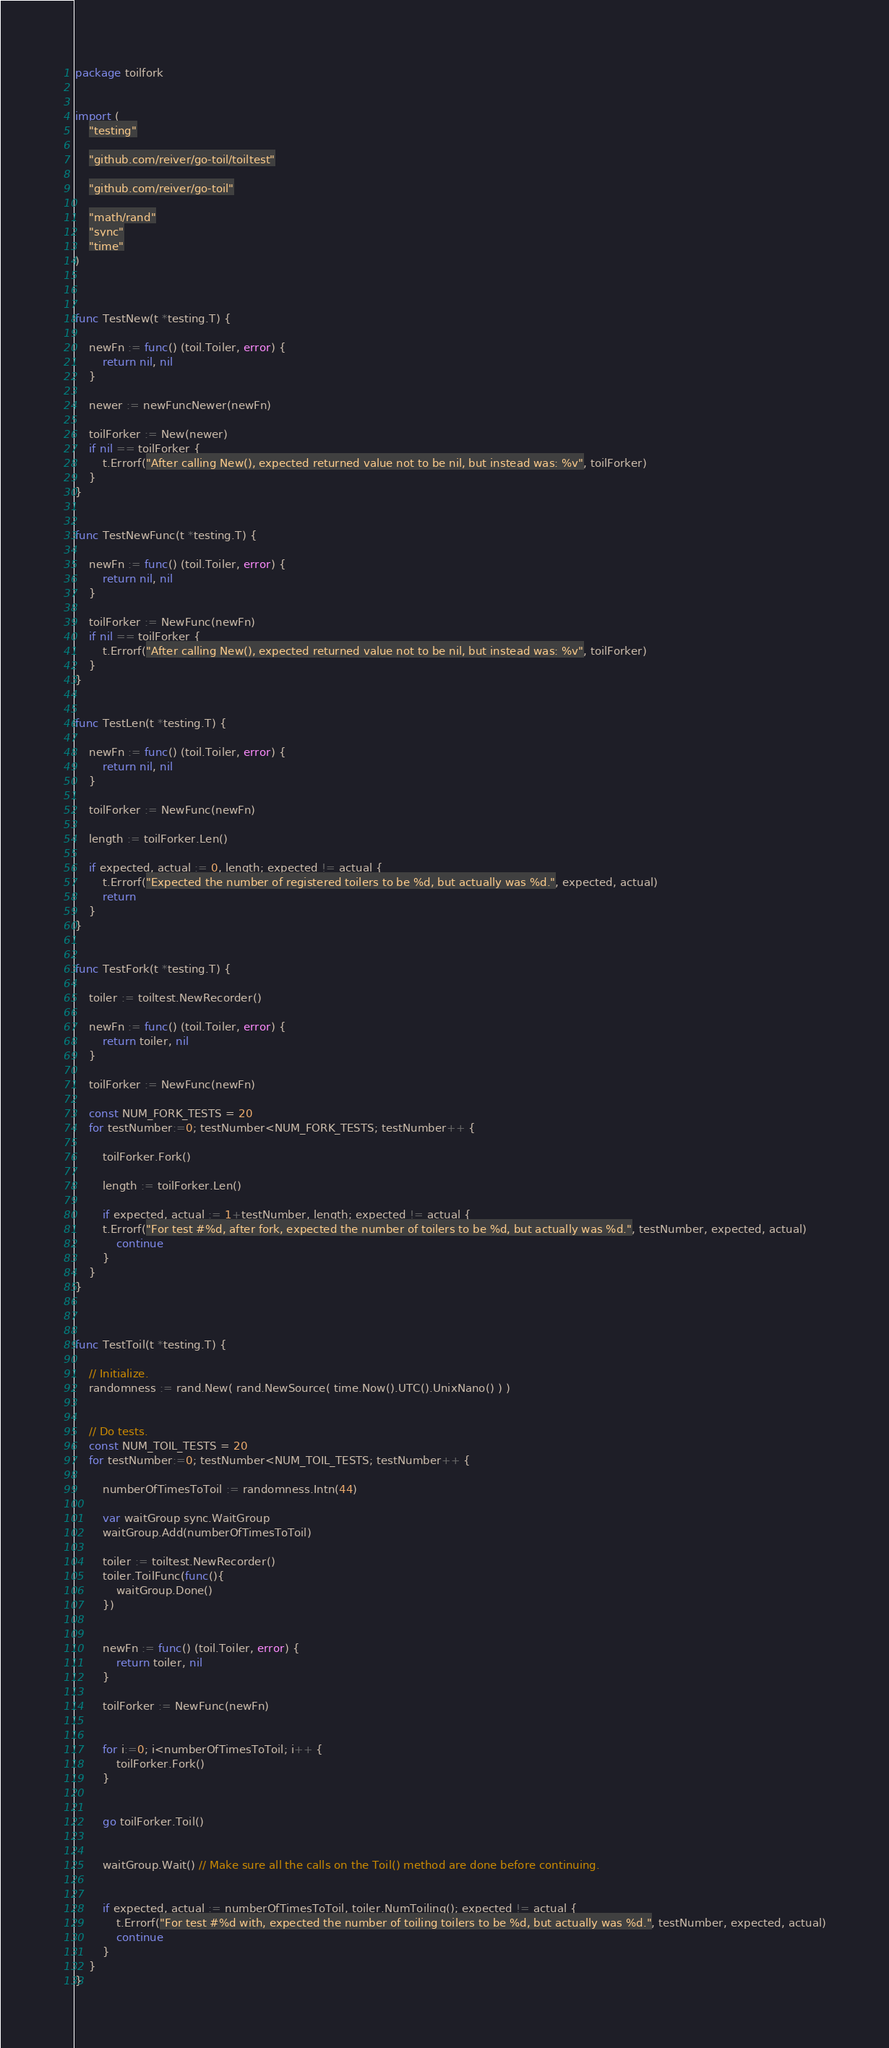Convert code to text. <code><loc_0><loc_0><loc_500><loc_500><_Go_>package toilfork


import (
	"testing"

	"github.com/reiver/go-toil/toiltest"

	"github.com/reiver/go-toil"

	"math/rand"
	"sync"
	"time"
)



func TestNew(t *testing.T) {

	newFn := func() (toil.Toiler, error) {
		return nil, nil
	}

	newer := newFuncNewer(newFn)

	toilForker := New(newer)
	if nil == toilForker {
		t.Errorf("After calling New(), expected returned value not to be nil, but instead was: %v", toilForker)
	}
}


func TestNewFunc(t *testing.T) {

	newFn := func() (toil.Toiler, error) {
		return nil, nil
	}

	toilForker := NewFunc(newFn)
	if nil == toilForker {
		t.Errorf("After calling New(), expected returned value not to be nil, but instead was: %v", toilForker)
	}
}


func TestLen(t *testing.T) {

	newFn := func() (toil.Toiler, error) {
		return nil, nil
	}

	toilForker := NewFunc(newFn)

	length := toilForker.Len()

	if expected, actual := 0, length; expected != actual {
		t.Errorf("Expected the number of registered toilers to be %d, but actually was %d.", expected, actual)
		return
	}
}


func TestFork(t *testing.T) {

	toiler := toiltest.NewRecorder()

	newFn := func() (toil.Toiler, error) {
		return toiler, nil
	}

	toilForker := NewFunc(newFn)

	const NUM_FORK_TESTS = 20
	for testNumber:=0; testNumber<NUM_FORK_TESTS; testNumber++ {

		toilForker.Fork()

		length := toilForker.Len()

		if expected, actual := 1+testNumber, length; expected != actual {
		t.Errorf("For test #%d, after fork, expected the number of toilers to be %d, but actually was %d.", testNumber, expected, actual)
			continue
		}
	}
}



func TestToil(t *testing.T) {

	// Initialize.
	randomness := rand.New( rand.NewSource( time.Now().UTC().UnixNano() ) )


	// Do tests.
	const NUM_TOIL_TESTS = 20
	for testNumber:=0; testNumber<NUM_TOIL_TESTS; testNumber++ {

		numberOfTimesToToil := randomness.Intn(44)

		var waitGroup sync.WaitGroup
		waitGroup.Add(numberOfTimesToToil)

		toiler := toiltest.NewRecorder()
		toiler.ToilFunc(func(){
			waitGroup.Done()
		})


		newFn := func() (toil.Toiler, error) {
			return toiler, nil
		}

		toilForker := NewFunc(newFn)


		for i:=0; i<numberOfTimesToToil; i++ {
			toilForker.Fork()
		}


		go toilForker.Toil()


		waitGroup.Wait() // Make sure all the calls on the Toil() method are done before continuing.


		if expected, actual := numberOfTimesToToil, toiler.NumToiling(); expected != actual {
			t.Errorf("For test #%d with, expected the number of toiling toilers to be %d, but actually was %d.", testNumber, expected, actual)
			continue
		}
	}
}
</code> 